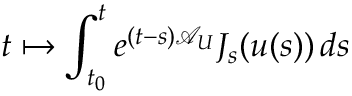Convert formula to latex. <formula><loc_0><loc_0><loc_500><loc_500>t \mapsto \int _ { t _ { 0 } } ^ { t } e ^ { ( t - s ) \mathcal { A } _ { U } } J _ { s } ( u ( s ) ) \, d s</formula> 